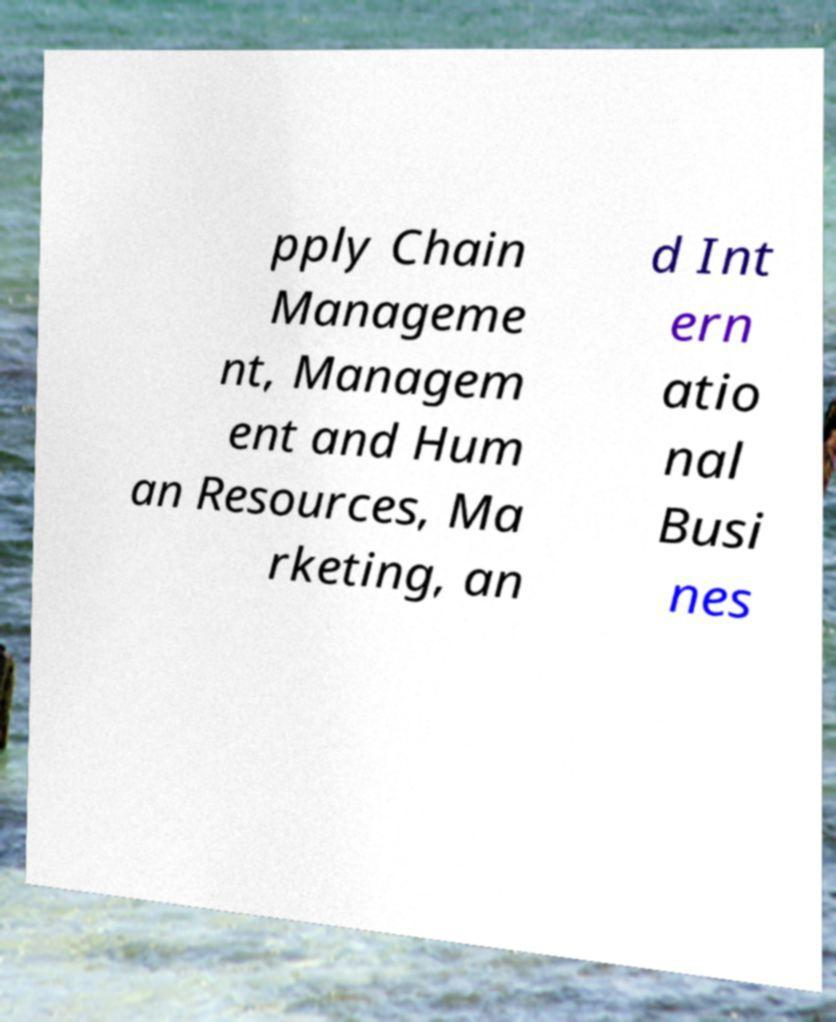What messages or text are displayed in this image? I need them in a readable, typed format. pply Chain Manageme nt, Managem ent and Hum an Resources, Ma rketing, an d Int ern atio nal Busi nes 